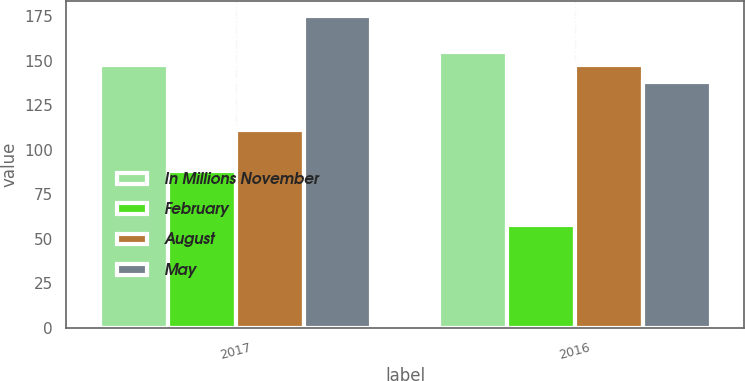<chart> <loc_0><loc_0><loc_500><loc_500><stacked_bar_chart><ecel><fcel>2017<fcel>2016<nl><fcel>In Millions November<fcel>148<fcel>155<nl><fcel>February<fcel>88<fcel>58<nl><fcel>August<fcel>111<fcel>148<nl><fcel>May<fcel>175<fcel>138<nl></chart> 